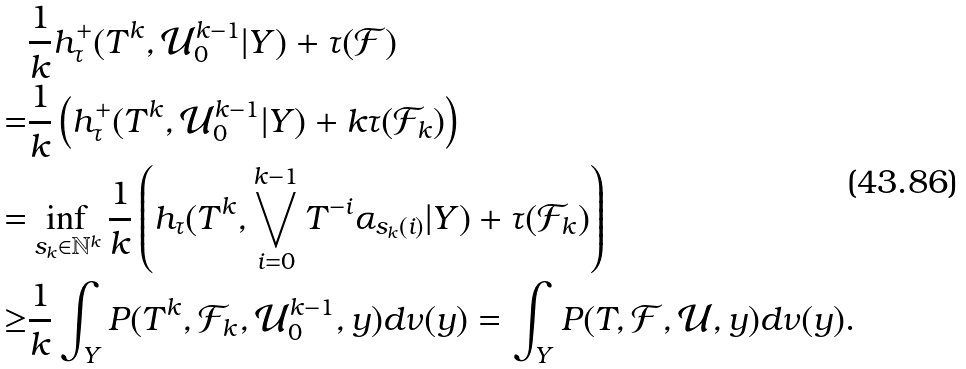<formula> <loc_0><loc_0><loc_500><loc_500>& \frac { 1 } { k } h _ { \tau } ^ { + } ( T ^ { k } , \mathcal { U } _ { 0 } ^ { k - 1 } | Y ) + \tau ( \mathcal { F } ) \\ = & \frac { 1 } { k } \left ( h _ { \tau } ^ { + } ( T ^ { k } , \mathcal { U } _ { 0 } ^ { k - 1 } | Y ) + k \tau ( \mathcal { F } _ { k } ) \right ) \\ = & \inf _ { s _ { k } \in \mathbb { N } ^ { k } } \frac { 1 } { k } \left ( h _ { \tau } ( T ^ { k } , \bigvee _ { i = 0 } ^ { k - 1 } T ^ { - i } \alpha _ { s _ { k } ( i ) } | Y ) + \tau ( \mathcal { F } _ { k } ) \right ) \\ \geq & \frac { 1 } { k } \int _ { Y } P ( T ^ { k } , \mathcal { F } _ { k } , \mathcal { U } _ { 0 } ^ { k - 1 } , y ) d \nu ( y ) = \int _ { Y } P ( T , \mathcal { F } , \mathcal { U } , y ) d \nu ( y ) .</formula> 